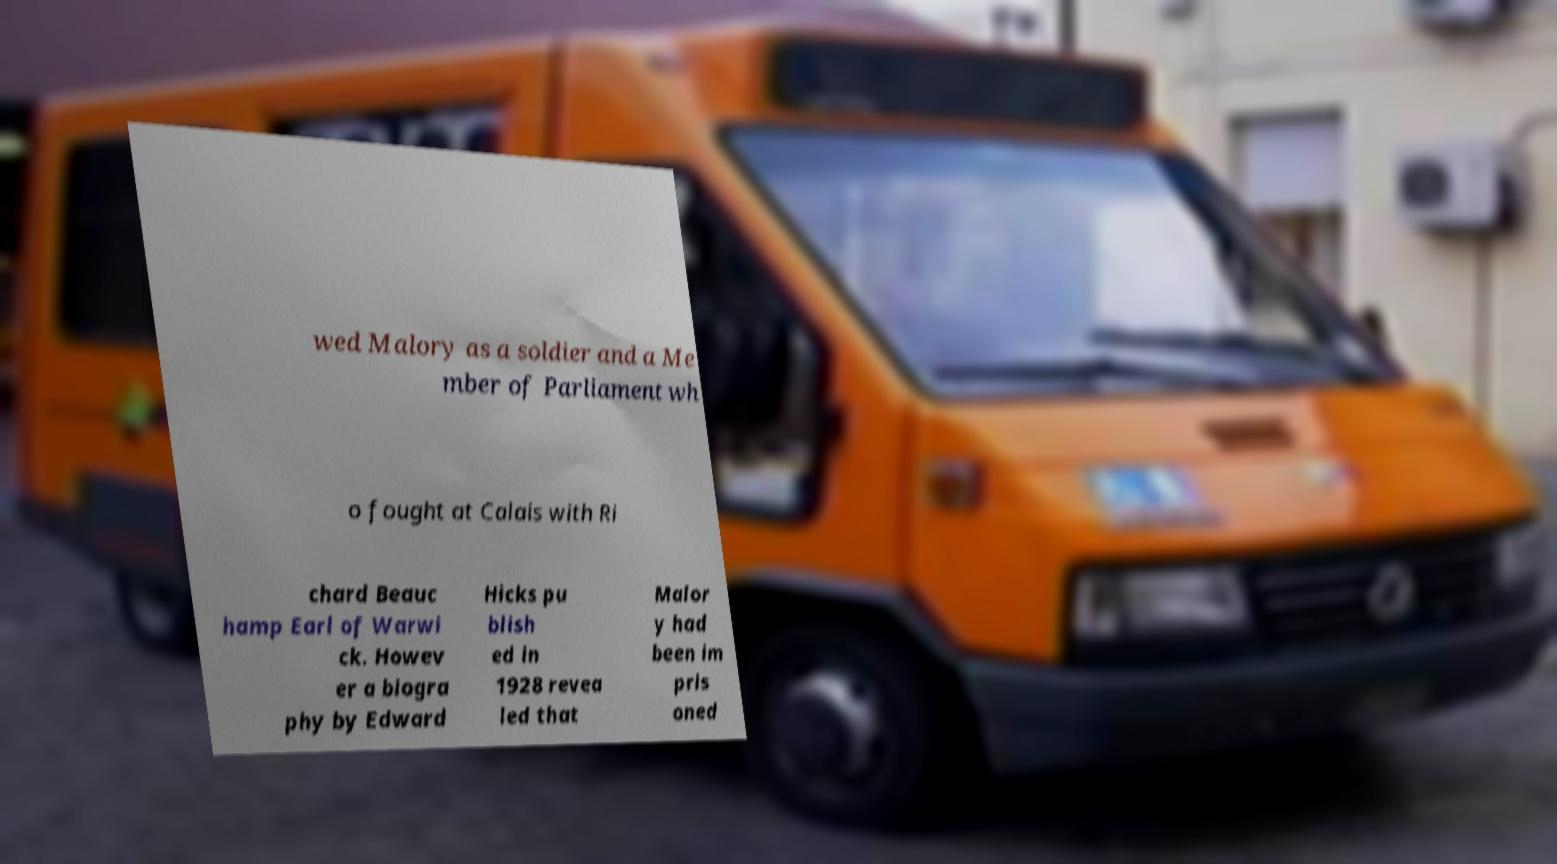Please identify and transcribe the text found in this image. wed Malory as a soldier and a Me mber of Parliament wh o fought at Calais with Ri chard Beauc hamp Earl of Warwi ck. Howev er a biogra phy by Edward Hicks pu blish ed in 1928 revea led that Malor y had been im pris oned 